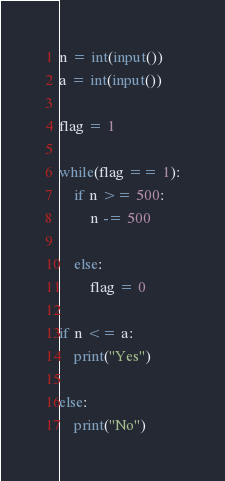<code> <loc_0><loc_0><loc_500><loc_500><_Python_>n = int(input())
a = int(input())

flag = 1

while(flag == 1):
    if n >= 500:
        n -= 500

    else:
        flag = 0

if n <= a:
    print("Yes")

else:
    print("No")
</code> 